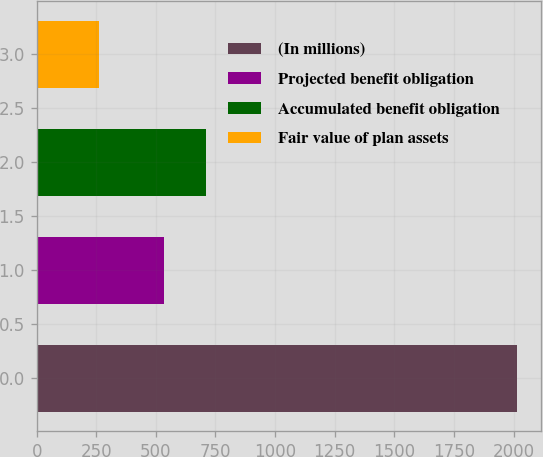<chart> <loc_0><loc_0><loc_500><loc_500><bar_chart><fcel>(In millions)<fcel>Projected benefit obligation<fcel>Accumulated benefit obligation<fcel>Fair value of plan assets<nl><fcel>2016<fcel>535<fcel>710.4<fcel>262<nl></chart> 